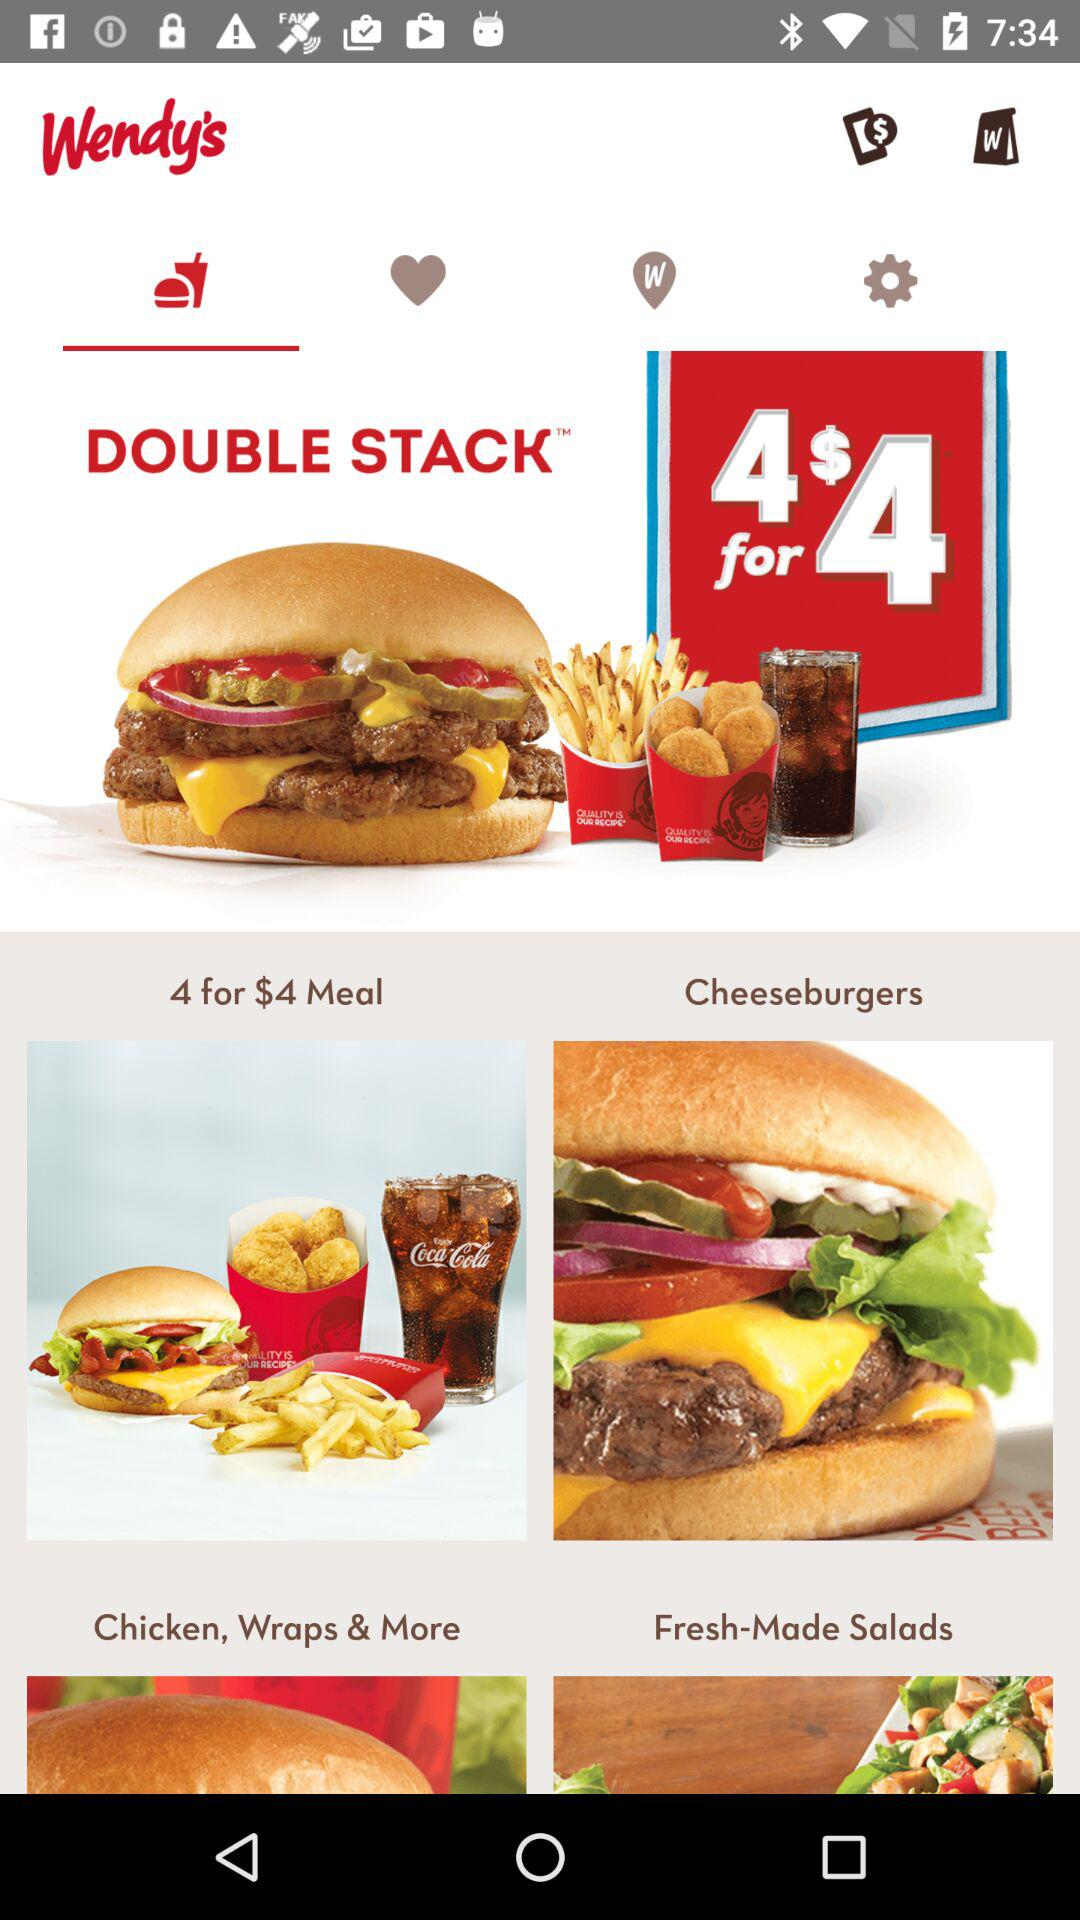What is the application name? The application name is "Wendy's". 